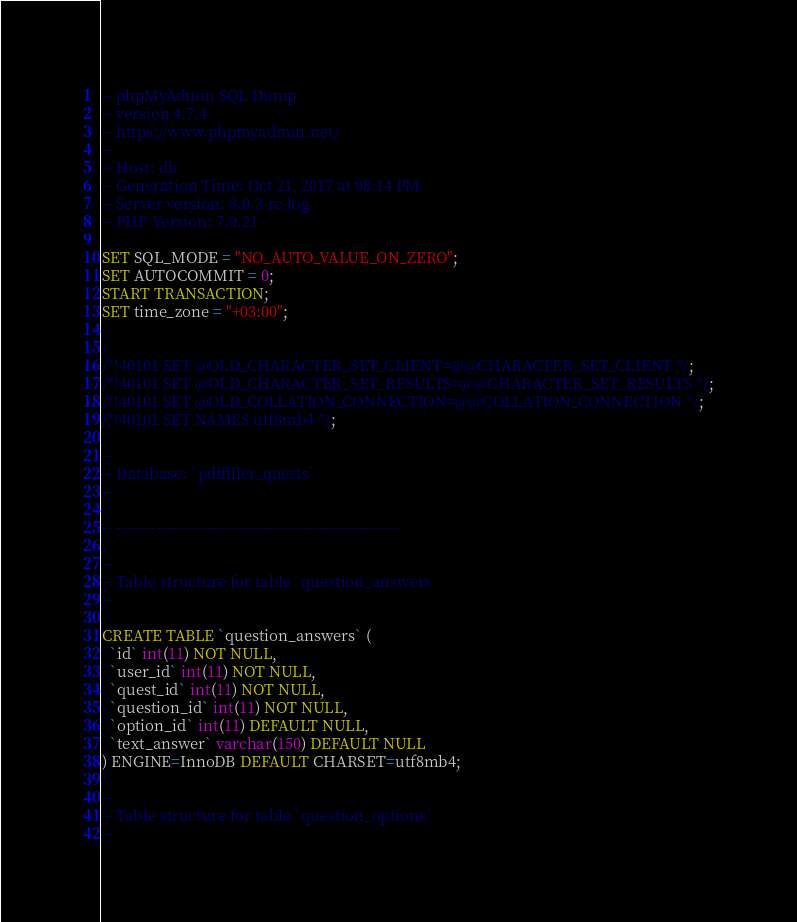<code> <loc_0><loc_0><loc_500><loc_500><_SQL_>-- phpMyAdmin SQL Dump
-- version 4.7.4
-- https://www.phpmyadmin.net/
--
-- Host: db
-- Generation Time: Oct 21, 2017 at 08:14 PM
-- Server version: 8.0.3-rc-log
-- PHP Version: 7.0.21

SET SQL_MODE = "NO_AUTO_VALUE_ON_ZERO";
SET AUTOCOMMIT = 0;
START TRANSACTION;
SET time_zone = "+03:00";


/*!40101 SET @OLD_CHARACTER_SET_CLIENT=@@CHARACTER_SET_CLIENT */;
/*!40101 SET @OLD_CHARACTER_SET_RESULTS=@@CHARACTER_SET_RESULTS */;
/*!40101 SET @OLD_COLLATION_CONNECTION=@@COLLATION_CONNECTION */;
/*!40101 SET NAMES utf8mb4 */;

--
-- Database: `pdffiller_quests`
--

-- --------------------------------------------------------

--
-- Table structure for table `question_answers`
--

CREATE TABLE `question_answers` (
  `id` int(11) NOT NULL,
  `user_id` int(11) NOT NULL,
  `quest_id` int(11) NOT NULL,
  `question_id` int(11) NOT NULL,
  `option_id` int(11) DEFAULT NULL,
  `text_answer` varchar(150) DEFAULT NULL
) ENGINE=InnoDB DEFAULT CHARSET=utf8mb4;

--
-- Table structure for table `question_options`
--
</code> 